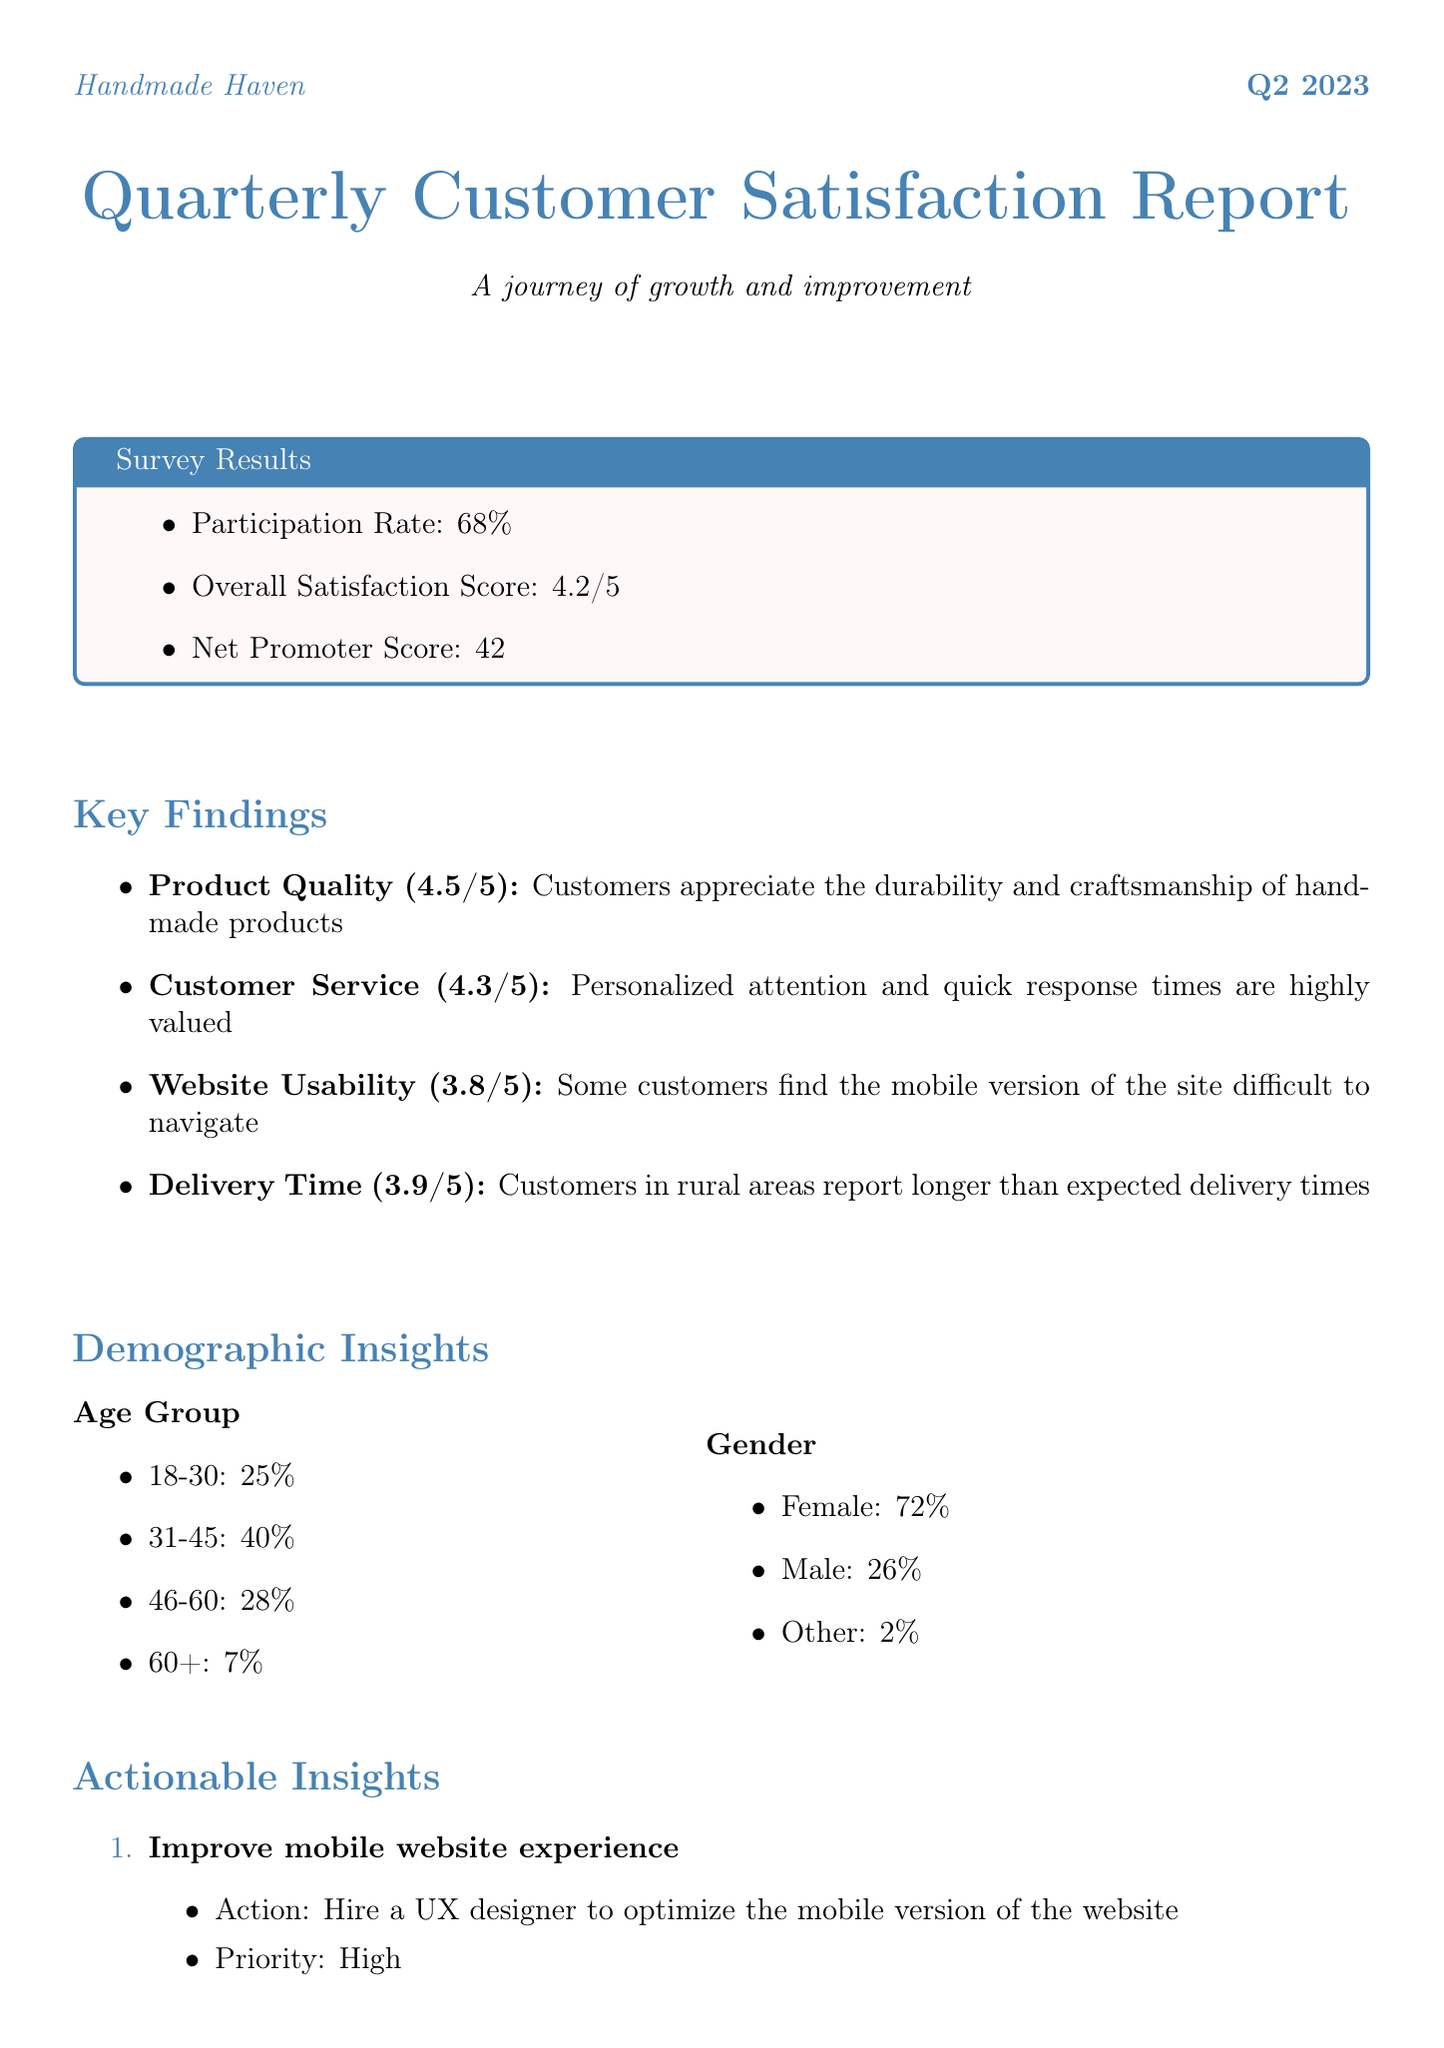What is the participation rate? The participation rate is provided in the survey results, indicating the percentage of customers who participated in the survey.
Answer: 68% What was the overall satisfaction score? The overall satisfaction score reflects the average customer satisfaction on a scale of 1 to 5, as indicated in the report.
Answer: 4.2 What is the net promoter score? The net promoter score measures customer loyalty and willingness to recommend the business, as mentioned in the survey results.
Answer: 42 Which area received the highest score? The area with the highest score indicates where customers are most satisfied, and this information is detailed under key findings.
Answer: Product Quality What actionable insight has a high priority? High priority actionable insights are specifically identified in the document for immediate implementation.
Answer: Improve mobile website experience What is a key strength compared to competitors? Strengths highlighting advantages over competitors are outlined, showcasing aspects that set the business apart.
Answer: Personalized customer service How many product lines are suggested for expansion? The report suggests the number of new product lines to introduce based on customer feedback, highlighting opportunities for growth.
Answer: 5 What demographic group comprises the largest percentage of respondents? The largest demographic group reflects the composition of the surveyed customers, helping to understand the target audience.
Answer: 31-45 What are the long-term future plans for the business? Long-term future plans detail the direction the business aims to take based on the insights gathered from the survey results.
Answer: Open a small physical store for local customers 